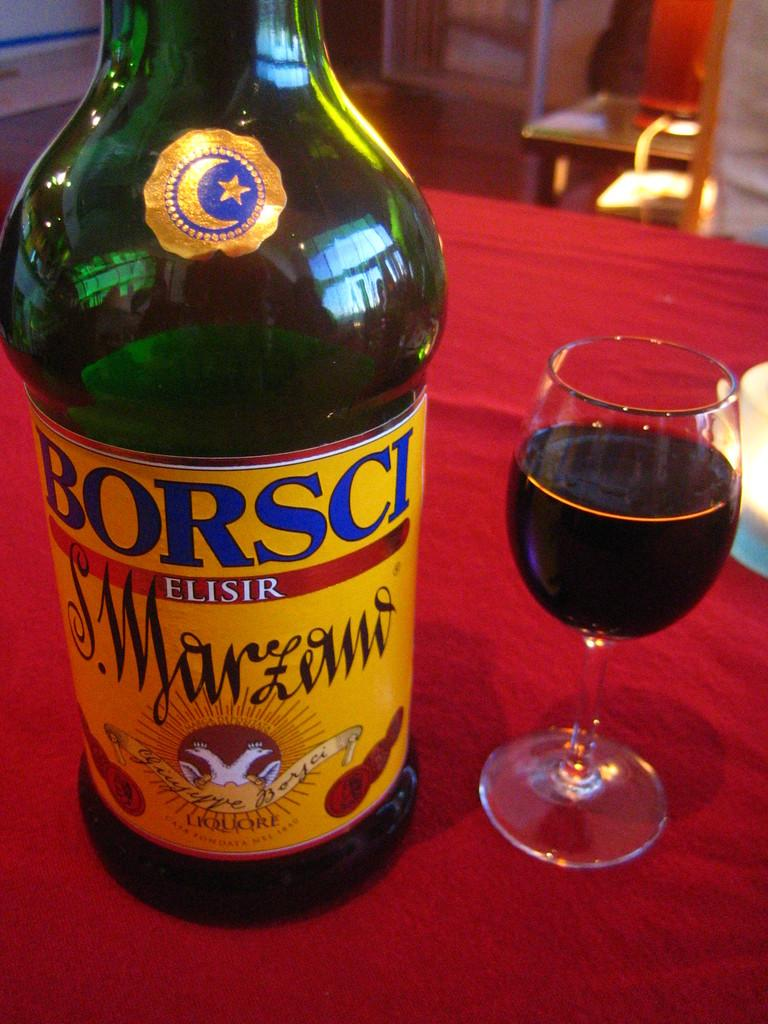<image>
Render a clear and concise summary of the photo. A bottle of Borsci sits on a red tablecloth by a half filled wineglass. 